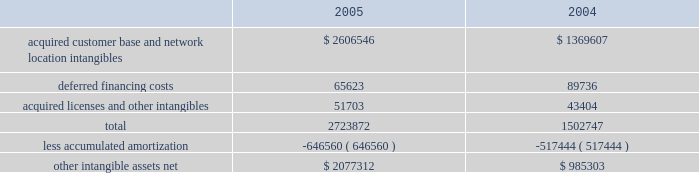American tower corporation and subsidiaries notes to consolidated financial statements 2014 ( continued ) the company has selected december 1 as the date to perform its annual impairment test .
In performing its 2005 and 2004 testing , the company completed an internal appraisal and estimated the fair value of the rental and management reporting unit that contains goodwill utilizing future discounted cash flows and market information .
Based on the appraisals performed , the company determined that goodwill in its rental and management segment was not impaired .
The company 2019s other intangible assets subject to amortization consist of the following as of december 31 , ( in thousands ) : .
The company amortizes its intangible assets over periods ranging from three to fifteen years .
Amortization of intangible assets for the years ended december 31 , 2005 and 2004 aggregated approximately $ 136.0 million and $ 97.8 million , respectively ( excluding amortization of deferred financing costs , which is included in interest expense ) .
The company expects to record amortization expense of approximately $ 183.6 million , $ 178.3 million , $ 174.4 million , $ 172.7 million and $ 170.3 million , for the years ended december 31 , 2006 , 2007 , 2008 , 2009 and 2010 , respectively .
These amounts are subject to changes in estimates until the preliminary allocation of the spectrasite purchase price is finalized .
Notes receivable in 2000 , the company loaned tv azteca , s.a .
De c.v .
( tv azteca ) , the owner of a major national television network in mexico , $ 119.8 million .
The loan , which initially bore interest at 12.87% ( 12.87 % ) , payable quarterly , was discounted by the company , as the fair value interest rate at the date of the loan was determined to be 14.25% ( 14.25 % ) .
The loan was amended effective january 1 , 2003 to increase the original interest rate to 13.11% ( 13.11 % ) .
As of december 31 , 2005 and 2004 , approximately $ 119.8 million undiscounted ( $ 108.2 million discounted ) under the loan was outstanding and included in notes receivable and other long-term assets in the accompanying consolidated balance sheets .
The term of the loan is seventy years ; however , the loan may be prepaid by tv azteca without penalty during the last fifty years of the agreement .
The discount on the loan is being amortized to interest income 2014tv azteca , net , using the effective interest method over the seventy-year term of the loan .
Simultaneous with the signing of the loan agreement , the company also entered into a seventy year economic rights agreement with tv azteca regarding space not used by tv azteca on approximately 190 of its broadcast towers .
In exchange for the issuance of the below market interest rate loan discussed above and the annual payment of $ 1.5 million to tv azteca ( under the economic rights agreement ) , the company has the right to market and lease the unused tower space on the broadcast towers ( the economic rights ) .
Tv azteca retains title to these towers and is responsible for their operation and maintenance .
The company is entitled to 100% ( 100 % ) of the revenues generated from leases with tenants on the unused space and is responsible for any incremental operating expenses associated with those tenants. .
What was the percent of the gradual decline in the recorded amortization expense from 2006 to 2007? 
Computations: ((183.6 - 178.3) / 178.3)
Answer: 0.02973. 